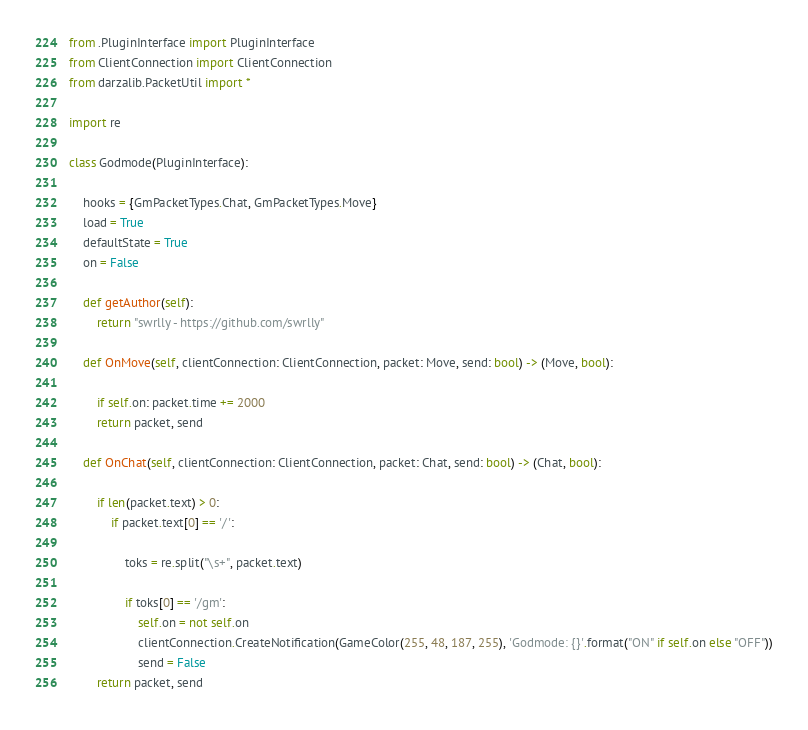<code> <loc_0><loc_0><loc_500><loc_500><_Python_>from .PluginInterface import PluginInterface
from ClientConnection import ClientConnection
from darzalib.PacketUtil import *

import re

class Godmode(PluginInterface):

    hooks = {GmPacketTypes.Chat, GmPacketTypes.Move}
    load = True
    defaultState = True
    on = False

    def getAuthor(self):
        return "swrlly - https://github.com/swrlly"

    def OnMove(self, clientConnection: ClientConnection, packet: Move, send: bool) -> (Move, bool):
        
        if self.on: packet.time += 2000
        return packet, send

    def OnChat(self, clientConnection: ClientConnection, packet: Chat, send: bool) -> (Chat, bool):
        
        if len(packet.text) > 0:
            if packet.text[0] == '/':

                toks = re.split("\s+", packet.text)

                if toks[0] == '/gm':
                    self.on = not self.on
                    clientConnection.CreateNotification(GameColor(255, 48, 187, 255), 'Godmode: {}'.format("ON" if self.on else "OFF"))
                    send = False
        return packet, send




</code> 